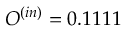Convert formula to latex. <formula><loc_0><loc_0><loc_500><loc_500>O ^ { ( i n ) } = 0 . 1 1 1 1</formula> 